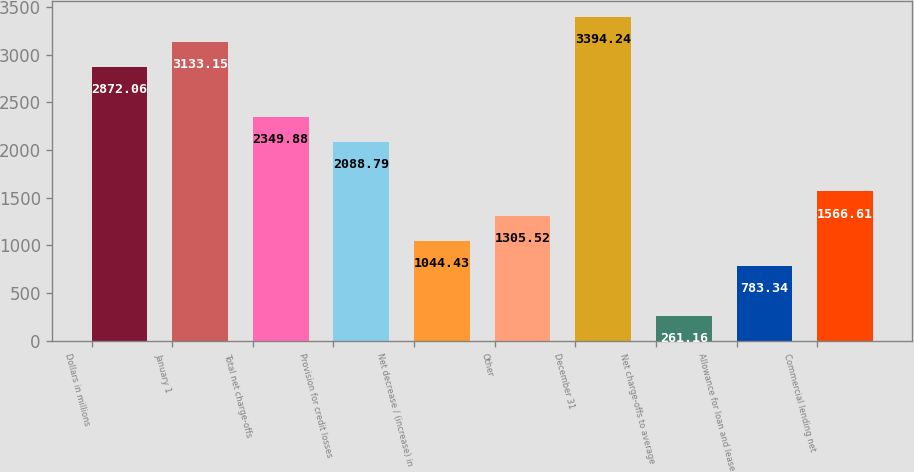<chart> <loc_0><loc_0><loc_500><loc_500><bar_chart><fcel>Dollars in millions<fcel>January 1<fcel>Total net charge-offs<fcel>Provision for credit losses<fcel>Net decrease / (increase) in<fcel>Other<fcel>December 31<fcel>Net charge-offs to average<fcel>Allowance for loan and lease<fcel>Commercial lending net<nl><fcel>2872.06<fcel>3133.15<fcel>2349.88<fcel>2088.79<fcel>1044.43<fcel>1305.52<fcel>3394.24<fcel>261.16<fcel>783.34<fcel>1566.61<nl></chart> 